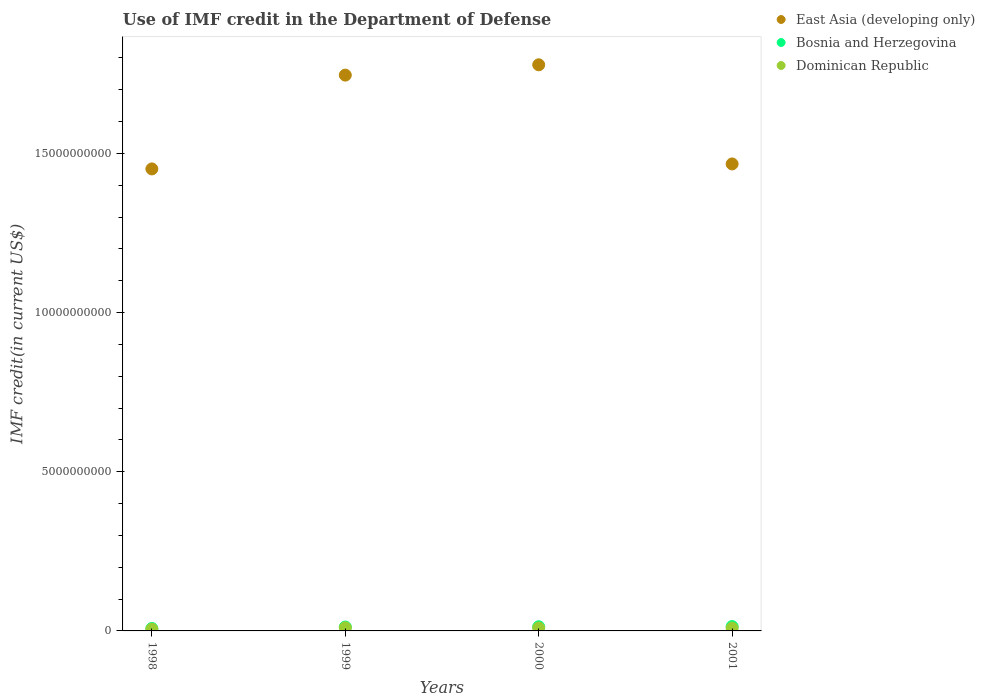What is the IMF credit in the Department of Defense in Dominican Republic in 1999?
Ensure brevity in your answer.  9.78e+07. Across all years, what is the maximum IMF credit in the Department of Defense in East Asia (developing only)?
Offer a very short reply. 1.78e+1. Across all years, what is the minimum IMF credit in the Department of Defense in East Asia (developing only)?
Ensure brevity in your answer.  1.45e+1. In which year was the IMF credit in the Department of Defense in Dominican Republic maximum?
Ensure brevity in your answer.  1999. In which year was the IMF credit in the Department of Defense in Bosnia and Herzegovina minimum?
Make the answer very short. 1998. What is the total IMF credit in the Department of Defense in East Asia (developing only) in the graph?
Your response must be concise. 6.44e+1. What is the difference between the IMF credit in the Department of Defense in East Asia (developing only) in 2000 and that in 2001?
Your answer should be very brief. 3.11e+09. What is the difference between the IMF credit in the Department of Defense in Bosnia and Herzegovina in 1998 and the IMF credit in the Department of Defense in East Asia (developing only) in 1999?
Provide a short and direct response. -1.74e+1. What is the average IMF credit in the Department of Defense in East Asia (developing only) per year?
Your answer should be compact. 1.61e+1. In the year 2000, what is the difference between the IMF credit in the Department of Defense in Bosnia and Herzegovina and IMF credit in the Department of Defense in Dominican Republic?
Offer a terse response. 3.86e+07. In how many years, is the IMF credit in the Department of Defense in Bosnia and Herzegovina greater than 13000000000 US$?
Offer a very short reply. 0. What is the ratio of the IMF credit in the Department of Defense in Dominican Republic in 1998 to that in 2001?
Keep it short and to the point. 0.62. What is the difference between the highest and the second highest IMF credit in the Department of Defense in Bosnia and Herzegovina?
Make the answer very short. 5.31e+06. What is the difference between the highest and the lowest IMF credit in the Department of Defense in Bosnia and Herzegovina?
Offer a very short reply. 6.00e+07. In how many years, is the IMF credit in the Department of Defense in Bosnia and Herzegovina greater than the average IMF credit in the Department of Defense in Bosnia and Herzegovina taken over all years?
Make the answer very short. 3. Is the sum of the IMF credit in the Department of Defense in East Asia (developing only) in 1999 and 2000 greater than the maximum IMF credit in the Department of Defense in Dominican Republic across all years?
Give a very brief answer. Yes. Is it the case that in every year, the sum of the IMF credit in the Department of Defense in Bosnia and Herzegovina and IMF credit in the Department of Defense in Dominican Republic  is greater than the IMF credit in the Department of Defense in East Asia (developing only)?
Offer a terse response. No. Does the IMF credit in the Department of Defense in Bosnia and Herzegovina monotonically increase over the years?
Offer a very short reply. Yes. How many dotlines are there?
Ensure brevity in your answer.  3. How many years are there in the graph?
Your response must be concise. 4. Where does the legend appear in the graph?
Your answer should be compact. Top right. How are the legend labels stacked?
Your answer should be compact. Vertical. What is the title of the graph?
Your answer should be compact. Use of IMF credit in the Department of Defense. Does "Greenland" appear as one of the legend labels in the graph?
Provide a short and direct response. No. What is the label or title of the Y-axis?
Your response must be concise. IMF credit(in current US$). What is the IMF credit(in current US$) of East Asia (developing only) in 1998?
Provide a succinct answer. 1.45e+1. What is the IMF credit(in current US$) in Bosnia and Herzegovina in 1998?
Keep it short and to the point. 7.68e+07. What is the IMF credit(in current US$) in Dominican Republic in 1998?
Keep it short and to the point. 5.59e+07. What is the IMF credit(in current US$) in East Asia (developing only) in 1999?
Your answer should be compact. 1.75e+1. What is the IMF credit(in current US$) of Bosnia and Herzegovina in 1999?
Offer a very short reply. 1.22e+08. What is the IMF credit(in current US$) in Dominican Republic in 1999?
Provide a short and direct response. 9.78e+07. What is the IMF credit(in current US$) in East Asia (developing only) in 2000?
Keep it short and to the point. 1.78e+1. What is the IMF credit(in current US$) in Bosnia and Herzegovina in 2000?
Your response must be concise. 1.31e+08. What is the IMF credit(in current US$) in Dominican Republic in 2000?
Your response must be concise. 9.29e+07. What is the IMF credit(in current US$) of East Asia (developing only) in 2001?
Offer a terse response. 1.47e+1. What is the IMF credit(in current US$) in Bosnia and Herzegovina in 2001?
Make the answer very short. 1.37e+08. What is the IMF credit(in current US$) of Dominican Republic in 2001?
Keep it short and to the point. 8.96e+07. Across all years, what is the maximum IMF credit(in current US$) in East Asia (developing only)?
Keep it short and to the point. 1.78e+1. Across all years, what is the maximum IMF credit(in current US$) in Bosnia and Herzegovina?
Give a very brief answer. 1.37e+08. Across all years, what is the maximum IMF credit(in current US$) of Dominican Republic?
Make the answer very short. 9.78e+07. Across all years, what is the minimum IMF credit(in current US$) of East Asia (developing only)?
Ensure brevity in your answer.  1.45e+1. Across all years, what is the minimum IMF credit(in current US$) of Bosnia and Herzegovina?
Keep it short and to the point. 7.68e+07. Across all years, what is the minimum IMF credit(in current US$) of Dominican Republic?
Your answer should be compact. 5.59e+07. What is the total IMF credit(in current US$) in East Asia (developing only) in the graph?
Keep it short and to the point. 6.44e+1. What is the total IMF credit(in current US$) of Bosnia and Herzegovina in the graph?
Your response must be concise. 4.67e+08. What is the total IMF credit(in current US$) in Dominican Republic in the graph?
Offer a very short reply. 3.36e+08. What is the difference between the IMF credit(in current US$) in East Asia (developing only) in 1998 and that in 1999?
Your answer should be compact. -2.95e+09. What is the difference between the IMF credit(in current US$) of Bosnia and Herzegovina in 1998 and that in 1999?
Make the answer very short. -4.52e+07. What is the difference between the IMF credit(in current US$) in Dominican Republic in 1998 and that in 1999?
Give a very brief answer. -4.19e+07. What is the difference between the IMF credit(in current US$) of East Asia (developing only) in 1998 and that in 2000?
Offer a terse response. -3.27e+09. What is the difference between the IMF credit(in current US$) of Bosnia and Herzegovina in 1998 and that in 2000?
Your response must be concise. -5.47e+07. What is the difference between the IMF credit(in current US$) in Dominican Republic in 1998 and that in 2000?
Your answer should be very brief. -3.70e+07. What is the difference between the IMF credit(in current US$) of East Asia (developing only) in 1998 and that in 2001?
Your answer should be compact. -1.56e+08. What is the difference between the IMF credit(in current US$) in Bosnia and Herzegovina in 1998 and that in 2001?
Offer a very short reply. -6.00e+07. What is the difference between the IMF credit(in current US$) in Dominican Republic in 1998 and that in 2001?
Provide a short and direct response. -3.37e+07. What is the difference between the IMF credit(in current US$) of East Asia (developing only) in 1999 and that in 2000?
Provide a short and direct response. -3.25e+08. What is the difference between the IMF credit(in current US$) of Bosnia and Herzegovina in 1999 and that in 2000?
Your answer should be compact. -9.46e+06. What is the difference between the IMF credit(in current US$) of Dominican Republic in 1999 and that in 2000?
Give a very brief answer. 4.96e+06. What is the difference between the IMF credit(in current US$) of East Asia (developing only) in 1999 and that in 2001?
Make the answer very short. 2.79e+09. What is the difference between the IMF credit(in current US$) in Bosnia and Herzegovina in 1999 and that in 2001?
Give a very brief answer. -1.48e+07. What is the difference between the IMF credit(in current US$) in Dominican Republic in 1999 and that in 2001?
Offer a terse response. 8.25e+06. What is the difference between the IMF credit(in current US$) in East Asia (developing only) in 2000 and that in 2001?
Give a very brief answer. 3.11e+09. What is the difference between the IMF credit(in current US$) of Bosnia and Herzegovina in 2000 and that in 2001?
Provide a succinct answer. -5.31e+06. What is the difference between the IMF credit(in current US$) in Dominican Republic in 2000 and that in 2001?
Your answer should be very brief. 3.29e+06. What is the difference between the IMF credit(in current US$) of East Asia (developing only) in 1998 and the IMF credit(in current US$) of Bosnia and Herzegovina in 1999?
Make the answer very short. 1.44e+1. What is the difference between the IMF credit(in current US$) in East Asia (developing only) in 1998 and the IMF credit(in current US$) in Dominican Republic in 1999?
Your response must be concise. 1.44e+1. What is the difference between the IMF credit(in current US$) of Bosnia and Herzegovina in 1998 and the IMF credit(in current US$) of Dominican Republic in 1999?
Offer a very short reply. -2.10e+07. What is the difference between the IMF credit(in current US$) in East Asia (developing only) in 1998 and the IMF credit(in current US$) in Bosnia and Herzegovina in 2000?
Ensure brevity in your answer.  1.44e+1. What is the difference between the IMF credit(in current US$) in East Asia (developing only) in 1998 and the IMF credit(in current US$) in Dominican Republic in 2000?
Your answer should be very brief. 1.44e+1. What is the difference between the IMF credit(in current US$) of Bosnia and Herzegovina in 1998 and the IMF credit(in current US$) of Dominican Republic in 2000?
Give a very brief answer. -1.61e+07. What is the difference between the IMF credit(in current US$) in East Asia (developing only) in 1998 and the IMF credit(in current US$) in Bosnia and Herzegovina in 2001?
Provide a succinct answer. 1.44e+1. What is the difference between the IMF credit(in current US$) of East Asia (developing only) in 1998 and the IMF credit(in current US$) of Dominican Republic in 2001?
Provide a short and direct response. 1.44e+1. What is the difference between the IMF credit(in current US$) in Bosnia and Herzegovina in 1998 and the IMF credit(in current US$) in Dominican Republic in 2001?
Give a very brief answer. -1.28e+07. What is the difference between the IMF credit(in current US$) of East Asia (developing only) in 1999 and the IMF credit(in current US$) of Bosnia and Herzegovina in 2000?
Your response must be concise. 1.73e+1. What is the difference between the IMF credit(in current US$) in East Asia (developing only) in 1999 and the IMF credit(in current US$) in Dominican Republic in 2000?
Ensure brevity in your answer.  1.74e+1. What is the difference between the IMF credit(in current US$) in Bosnia and Herzegovina in 1999 and the IMF credit(in current US$) in Dominican Republic in 2000?
Your response must be concise. 2.91e+07. What is the difference between the IMF credit(in current US$) in East Asia (developing only) in 1999 and the IMF credit(in current US$) in Bosnia and Herzegovina in 2001?
Your answer should be compact. 1.73e+1. What is the difference between the IMF credit(in current US$) of East Asia (developing only) in 1999 and the IMF credit(in current US$) of Dominican Republic in 2001?
Your answer should be compact. 1.74e+1. What is the difference between the IMF credit(in current US$) in Bosnia and Herzegovina in 1999 and the IMF credit(in current US$) in Dominican Republic in 2001?
Provide a short and direct response. 3.24e+07. What is the difference between the IMF credit(in current US$) in East Asia (developing only) in 2000 and the IMF credit(in current US$) in Bosnia and Herzegovina in 2001?
Offer a terse response. 1.76e+1. What is the difference between the IMF credit(in current US$) of East Asia (developing only) in 2000 and the IMF credit(in current US$) of Dominican Republic in 2001?
Offer a very short reply. 1.77e+1. What is the difference between the IMF credit(in current US$) in Bosnia and Herzegovina in 2000 and the IMF credit(in current US$) in Dominican Republic in 2001?
Give a very brief answer. 4.19e+07. What is the average IMF credit(in current US$) in East Asia (developing only) per year?
Provide a short and direct response. 1.61e+1. What is the average IMF credit(in current US$) of Bosnia and Herzegovina per year?
Offer a terse response. 1.17e+08. What is the average IMF credit(in current US$) in Dominican Republic per year?
Give a very brief answer. 8.41e+07. In the year 1998, what is the difference between the IMF credit(in current US$) of East Asia (developing only) and IMF credit(in current US$) of Bosnia and Herzegovina?
Offer a very short reply. 1.44e+1. In the year 1998, what is the difference between the IMF credit(in current US$) in East Asia (developing only) and IMF credit(in current US$) in Dominican Republic?
Your response must be concise. 1.45e+1. In the year 1998, what is the difference between the IMF credit(in current US$) in Bosnia and Herzegovina and IMF credit(in current US$) in Dominican Republic?
Provide a short and direct response. 2.09e+07. In the year 1999, what is the difference between the IMF credit(in current US$) of East Asia (developing only) and IMF credit(in current US$) of Bosnia and Herzegovina?
Keep it short and to the point. 1.73e+1. In the year 1999, what is the difference between the IMF credit(in current US$) of East Asia (developing only) and IMF credit(in current US$) of Dominican Republic?
Offer a very short reply. 1.74e+1. In the year 1999, what is the difference between the IMF credit(in current US$) in Bosnia and Herzegovina and IMF credit(in current US$) in Dominican Republic?
Provide a short and direct response. 2.42e+07. In the year 2000, what is the difference between the IMF credit(in current US$) of East Asia (developing only) and IMF credit(in current US$) of Bosnia and Herzegovina?
Provide a succinct answer. 1.76e+1. In the year 2000, what is the difference between the IMF credit(in current US$) of East Asia (developing only) and IMF credit(in current US$) of Dominican Republic?
Your response must be concise. 1.77e+1. In the year 2000, what is the difference between the IMF credit(in current US$) of Bosnia and Herzegovina and IMF credit(in current US$) of Dominican Republic?
Your answer should be very brief. 3.86e+07. In the year 2001, what is the difference between the IMF credit(in current US$) in East Asia (developing only) and IMF credit(in current US$) in Bosnia and Herzegovina?
Your answer should be very brief. 1.45e+1. In the year 2001, what is the difference between the IMF credit(in current US$) of East Asia (developing only) and IMF credit(in current US$) of Dominican Republic?
Make the answer very short. 1.46e+1. In the year 2001, what is the difference between the IMF credit(in current US$) of Bosnia and Herzegovina and IMF credit(in current US$) of Dominican Republic?
Your answer should be compact. 4.72e+07. What is the ratio of the IMF credit(in current US$) of East Asia (developing only) in 1998 to that in 1999?
Give a very brief answer. 0.83. What is the ratio of the IMF credit(in current US$) in Bosnia and Herzegovina in 1998 to that in 1999?
Your answer should be very brief. 0.63. What is the ratio of the IMF credit(in current US$) in Dominican Republic in 1998 to that in 1999?
Your answer should be very brief. 0.57. What is the ratio of the IMF credit(in current US$) of East Asia (developing only) in 1998 to that in 2000?
Offer a terse response. 0.82. What is the ratio of the IMF credit(in current US$) in Bosnia and Herzegovina in 1998 to that in 2000?
Keep it short and to the point. 0.58. What is the ratio of the IMF credit(in current US$) in Dominican Republic in 1998 to that in 2000?
Make the answer very short. 0.6. What is the ratio of the IMF credit(in current US$) of East Asia (developing only) in 1998 to that in 2001?
Provide a succinct answer. 0.99. What is the ratio of the IMF credit(in current US$) in Bosnia and Herzegovina in 1998 to that in 2001?
Offer a very short reply. 0.56. What is the ratio of the IMF credit(in current US$) of Dominican Republic in 1998 to that in 2001?
Offer a very short reply. 0.62. What is the ratio of the IMF credit(in current US$) of East Asia (developing only) in 1999 to that in 2000?
Provide a succinct answer. 0.98. What is the ratio of the IMF credit(in current US$) in Bosnia and Herzegovina in 1999 to that in 2000?
Your answer should be compact. 0.93. What is the ratio of the IMF credit(in current US$) of Dominican Republic in 1999 to that in 2000?
Offer a very short reply. 1.05. What is the ratio of the IMF credit(in current US$) of East Asia (developing only) in 1999 to that in 2001?
Ensure brevity in your answer.  1.19. What is the ratio of the IMF credit(in current US$) of Bosnia and Herzegovina in 1999 to that in 2001?
Give a very brief answer. 0.89. What is the ratio of the IMF credit(in current US$) of Dominican Republic in 1999 to that in 2001?
Offer a very short reply. 1.09. What is the ratio of the IMF credit(in current US$) in East Asia (developing only) in 2000 to that in 2001?
Provide a succinct answer. 1.21. What is the ratio of the IMF credit(in current US$) of Bosnia and Herzegovina in 2000 to that in 2001?
Your answer should be very brief. 0.96. What is the ratio of the IMF credit(in current US$) in Dominican Republic in 2000 to that in 2001?
Ensure brevity in your answer.  1.04. What is the difference between the highest and the second highest IMF credit(in current US$) of East Asia (developing only)?
Provide a short and direct response. 3.25e+08. What is the difference between the highest and the second highest IMF credit(in current US$) in Bosnia and Herzegovina?
Your answer should be very brief. 5.31e+06. What is the difference between the highest and the second highest IMF credit(in current US$) of Dominican Republic?
Provide a succinct answer. 4.96e+06. What is the difference between the highest and the lowest IMF credit(in current US$) of East Asia (developing only)?
Ensure brevity in your answer.  3.27e+09. What is the difference between the highest and the lowest IMF credit(in current US$) of Bosnia and Herzegovina?
Provide a succinct answer. 6.00e+07. What is the difference between the highest and the lowest IMF credit(in current US$) in Dominican Republic?
Provide a succinct answer. 4.19e+07. 